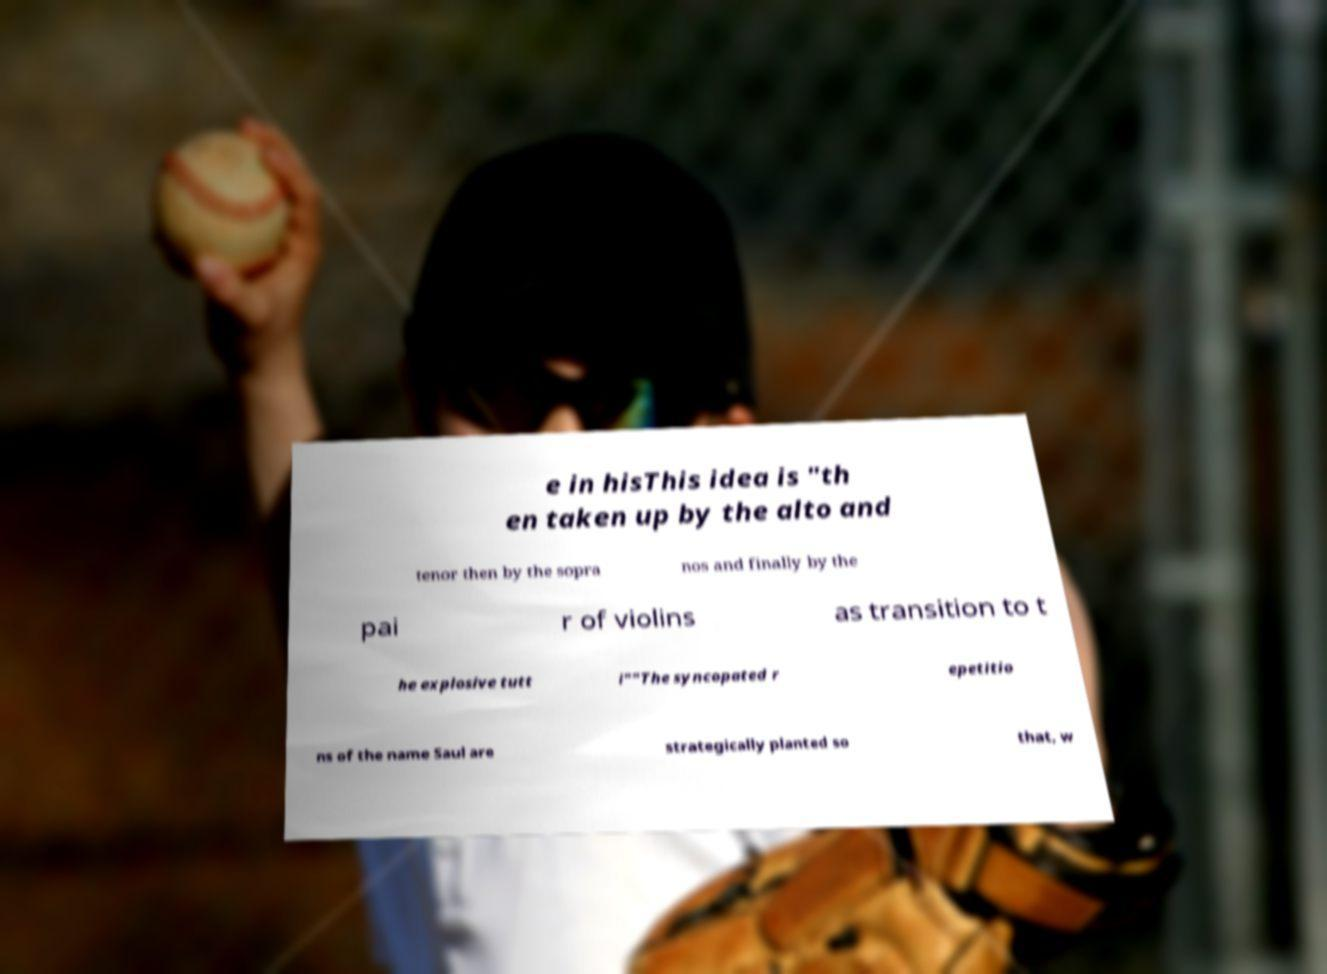Can you read and provide the text displayed in the image?This photo seems to have some interesting text. Can you extract and type it out for me? e in hisThis idea is "th en taken up by the alto and tenor then by the sopra nos and finally by the pai r of violins as transition to t he explosive tutt i""The syncopated r epetitio ns of the name Saul are strategically planted so that, w 